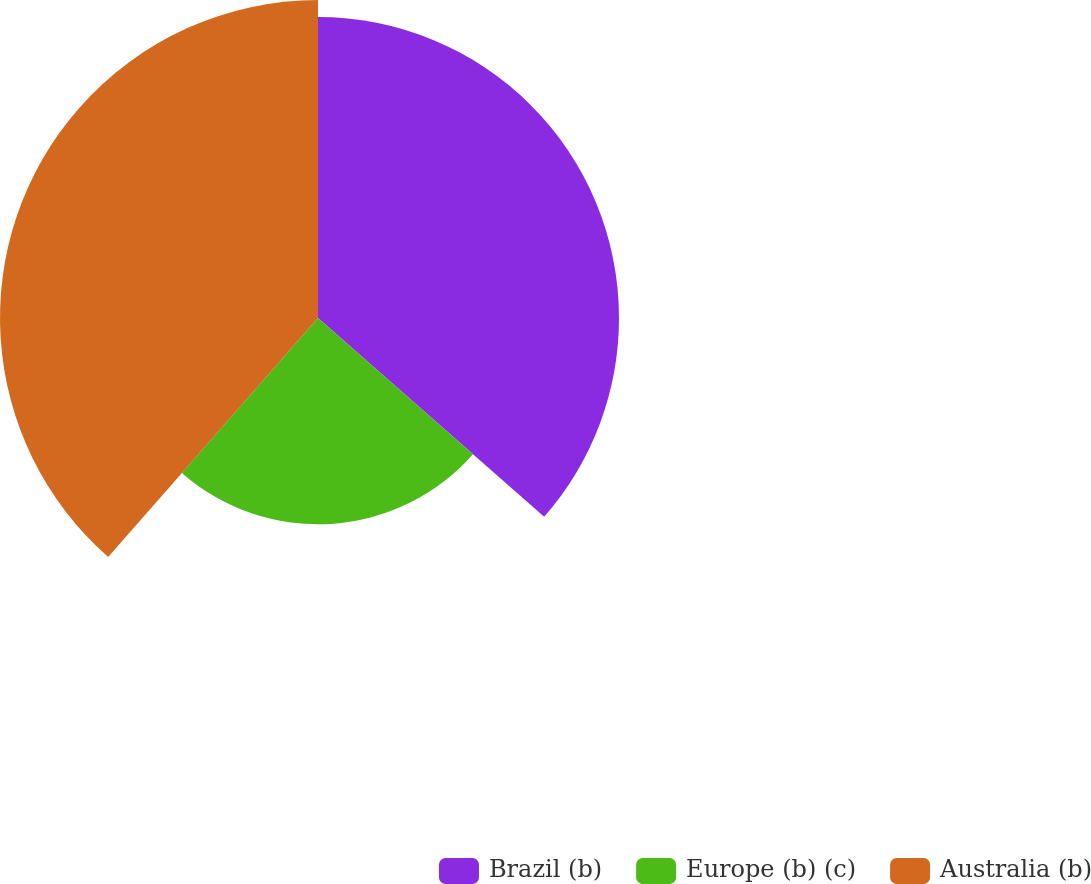Convert chart to OTSL. <chart><loc_0><loc_0><loc_500><loc_500><pie_chart><fcel>Brazil (b)<fcel>Europe (b) (c)<fcel>Australia (b)<nl><fcel>36.47%<fcel>25.0%<fcel>38.53%<nl></chart> 